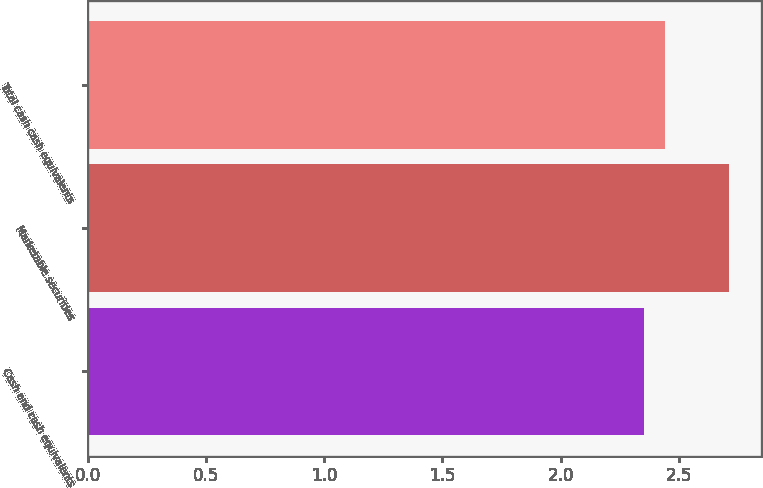Convert chart. <chart><loc_0><loc_0><loc_500><loc_500><bar_chart><fcel>Cash and cash equivalents<fcel>Marketable securities<fcel>Total cash cash equivalents<nl><fcel>2.35<fcel>2.71<fcel>2.44<nl></chart> 